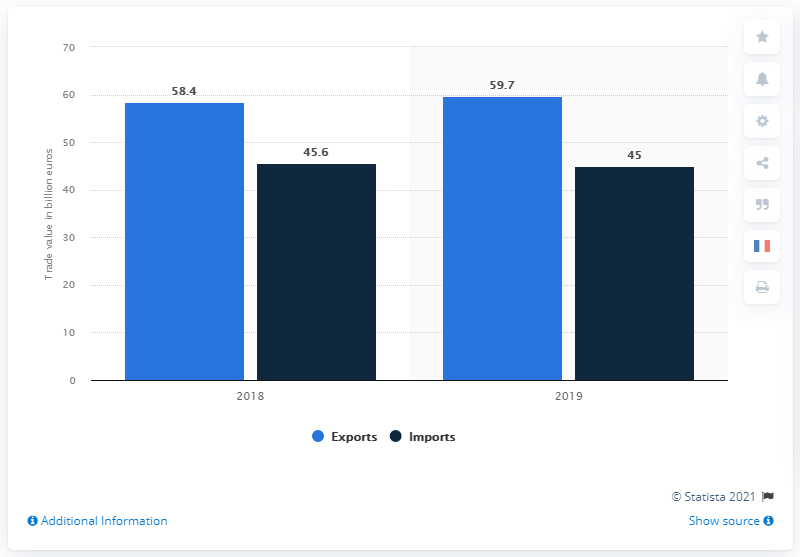What was the value of French exports of chemicals, cosmetics and perfumes in 2019?
 59.7 